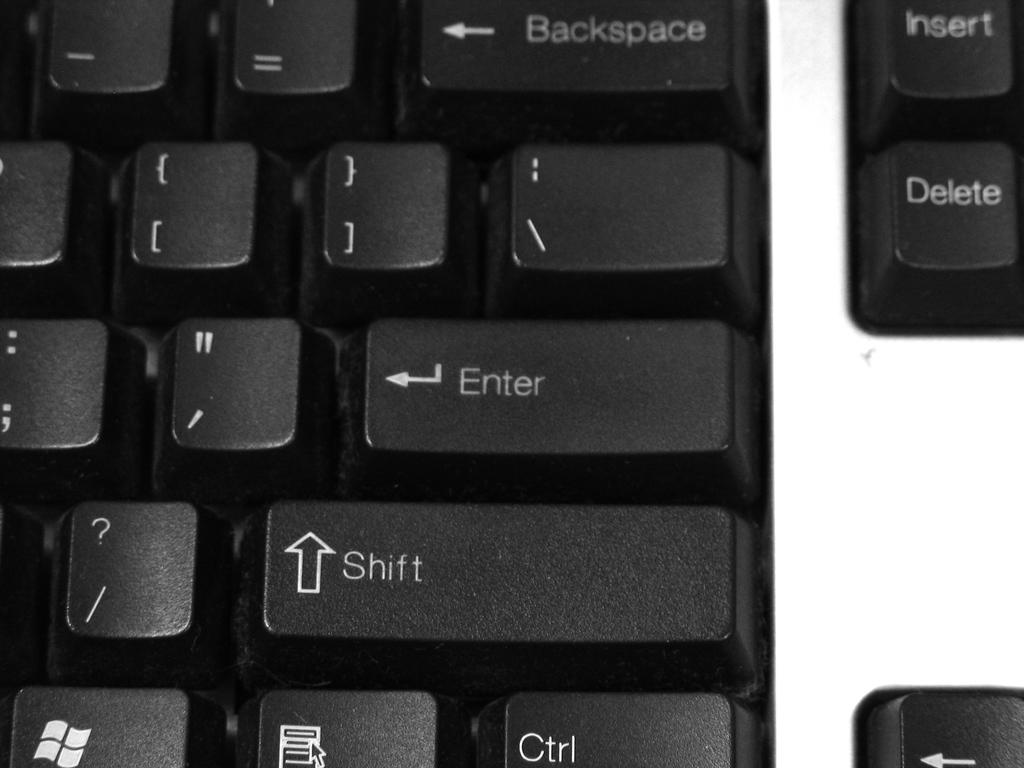<image>
Provide a brief description of the given image. A close up of a keyboard showing several keys including the enter and shift key. 